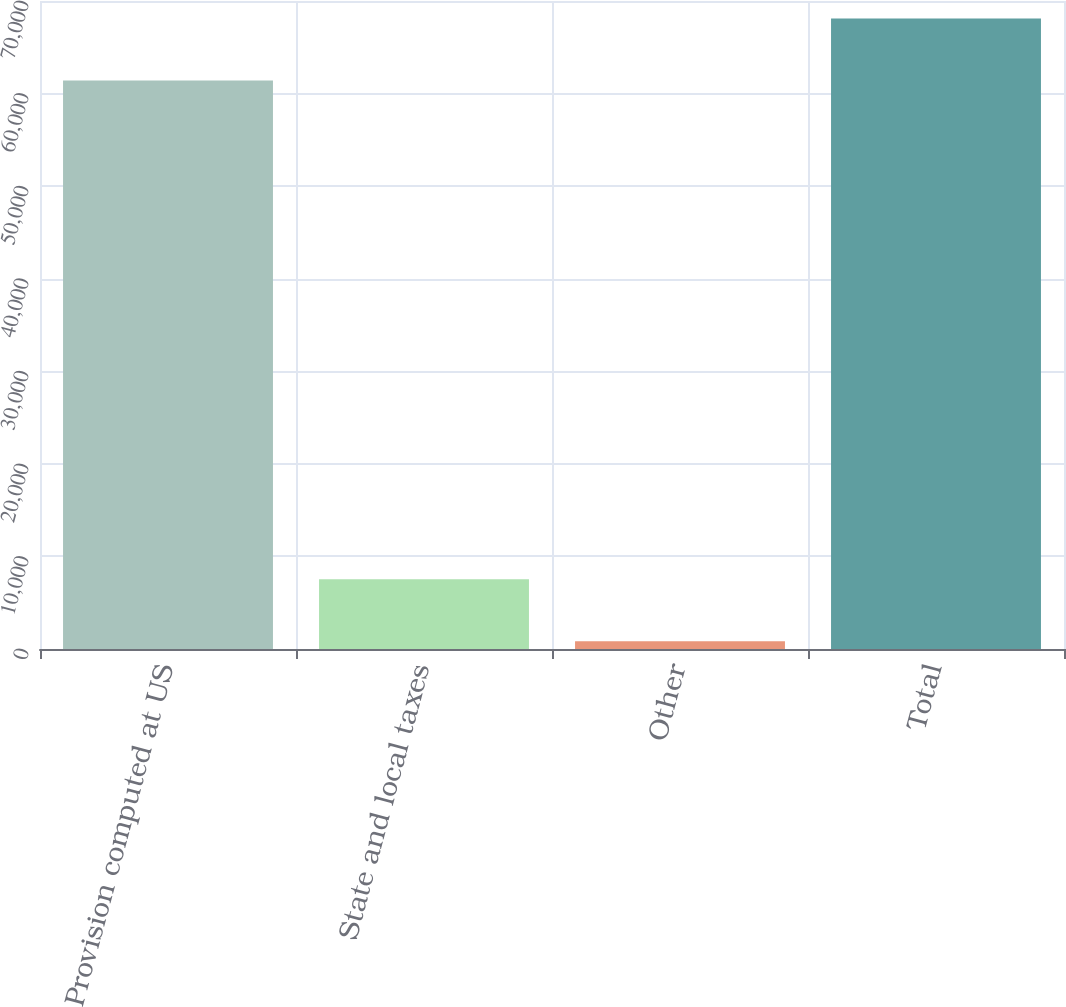Convert chart. <chart><loc_0><loc_0><loc_500><loc_500><bar_chart><fcel>Provision computed at US<fcel>State and local taxes<fcel>Other<fcel>Total<nl><fcel>61402<fcel>7537.3<fcel>829<fcel>68110.3<nl></chart> 